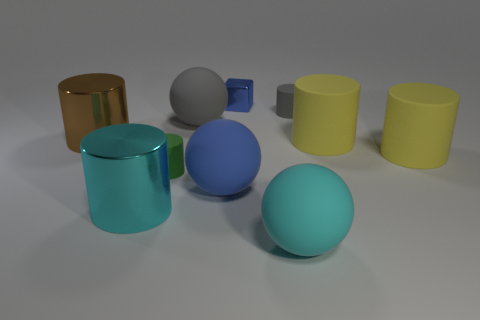Does the brown cylinder have the same material as the big cyan object on the right side of the large blue sphere?
Keep it short and to the point. No. There is a rubber object in front of the metal thing in front of the large brown metallic cylinder; how big is it?
Ensure brevity in your answer.  Large. Is there anything else that has the same color as the small metal object?
Ensure brevity in your answer.  Yes. Are the big sphere behind the big brown metallic object and the cyan object right of the cyan cylinder made of the same material?
Make the answer very short. Yes. There is a thing that is behind the large gray matte thing and right of the large cyan ball; what is its material?
Give a very brief answer. Rubber. Is the shape of the big gray object the same as the thing that is to the left of the cyan cylinder?
Give a very brief answer. No. What is the large ball that is behind the small cylinder in front of the cylinder behind the big brown metallic thing made of?
Give a very brief answer. Rubber. How many other objects are the same size as the cyan rubber ball?
Your answer should be compact. 6. There is a small matte object that is on the left side of the small matte thing that is on the right side of the tiny shiny object; how many green rubber things are behind it?
Your answer should be very brief. 0. What material is the blue thing behind the large metal thing behind the cyan shiny thing?
Your response must be concise. Metal. 